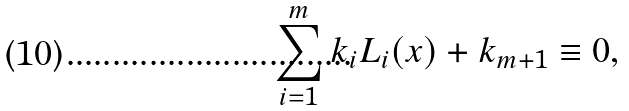Convert formula to latex. <formula><loc_0><loc_0><loc_500><loc_500>\sum _ { i = 1 } ^ { m } k _ { i } L _ { i } ( x ) + k _ { m + 1 } \equiv 0 ,</formula> 